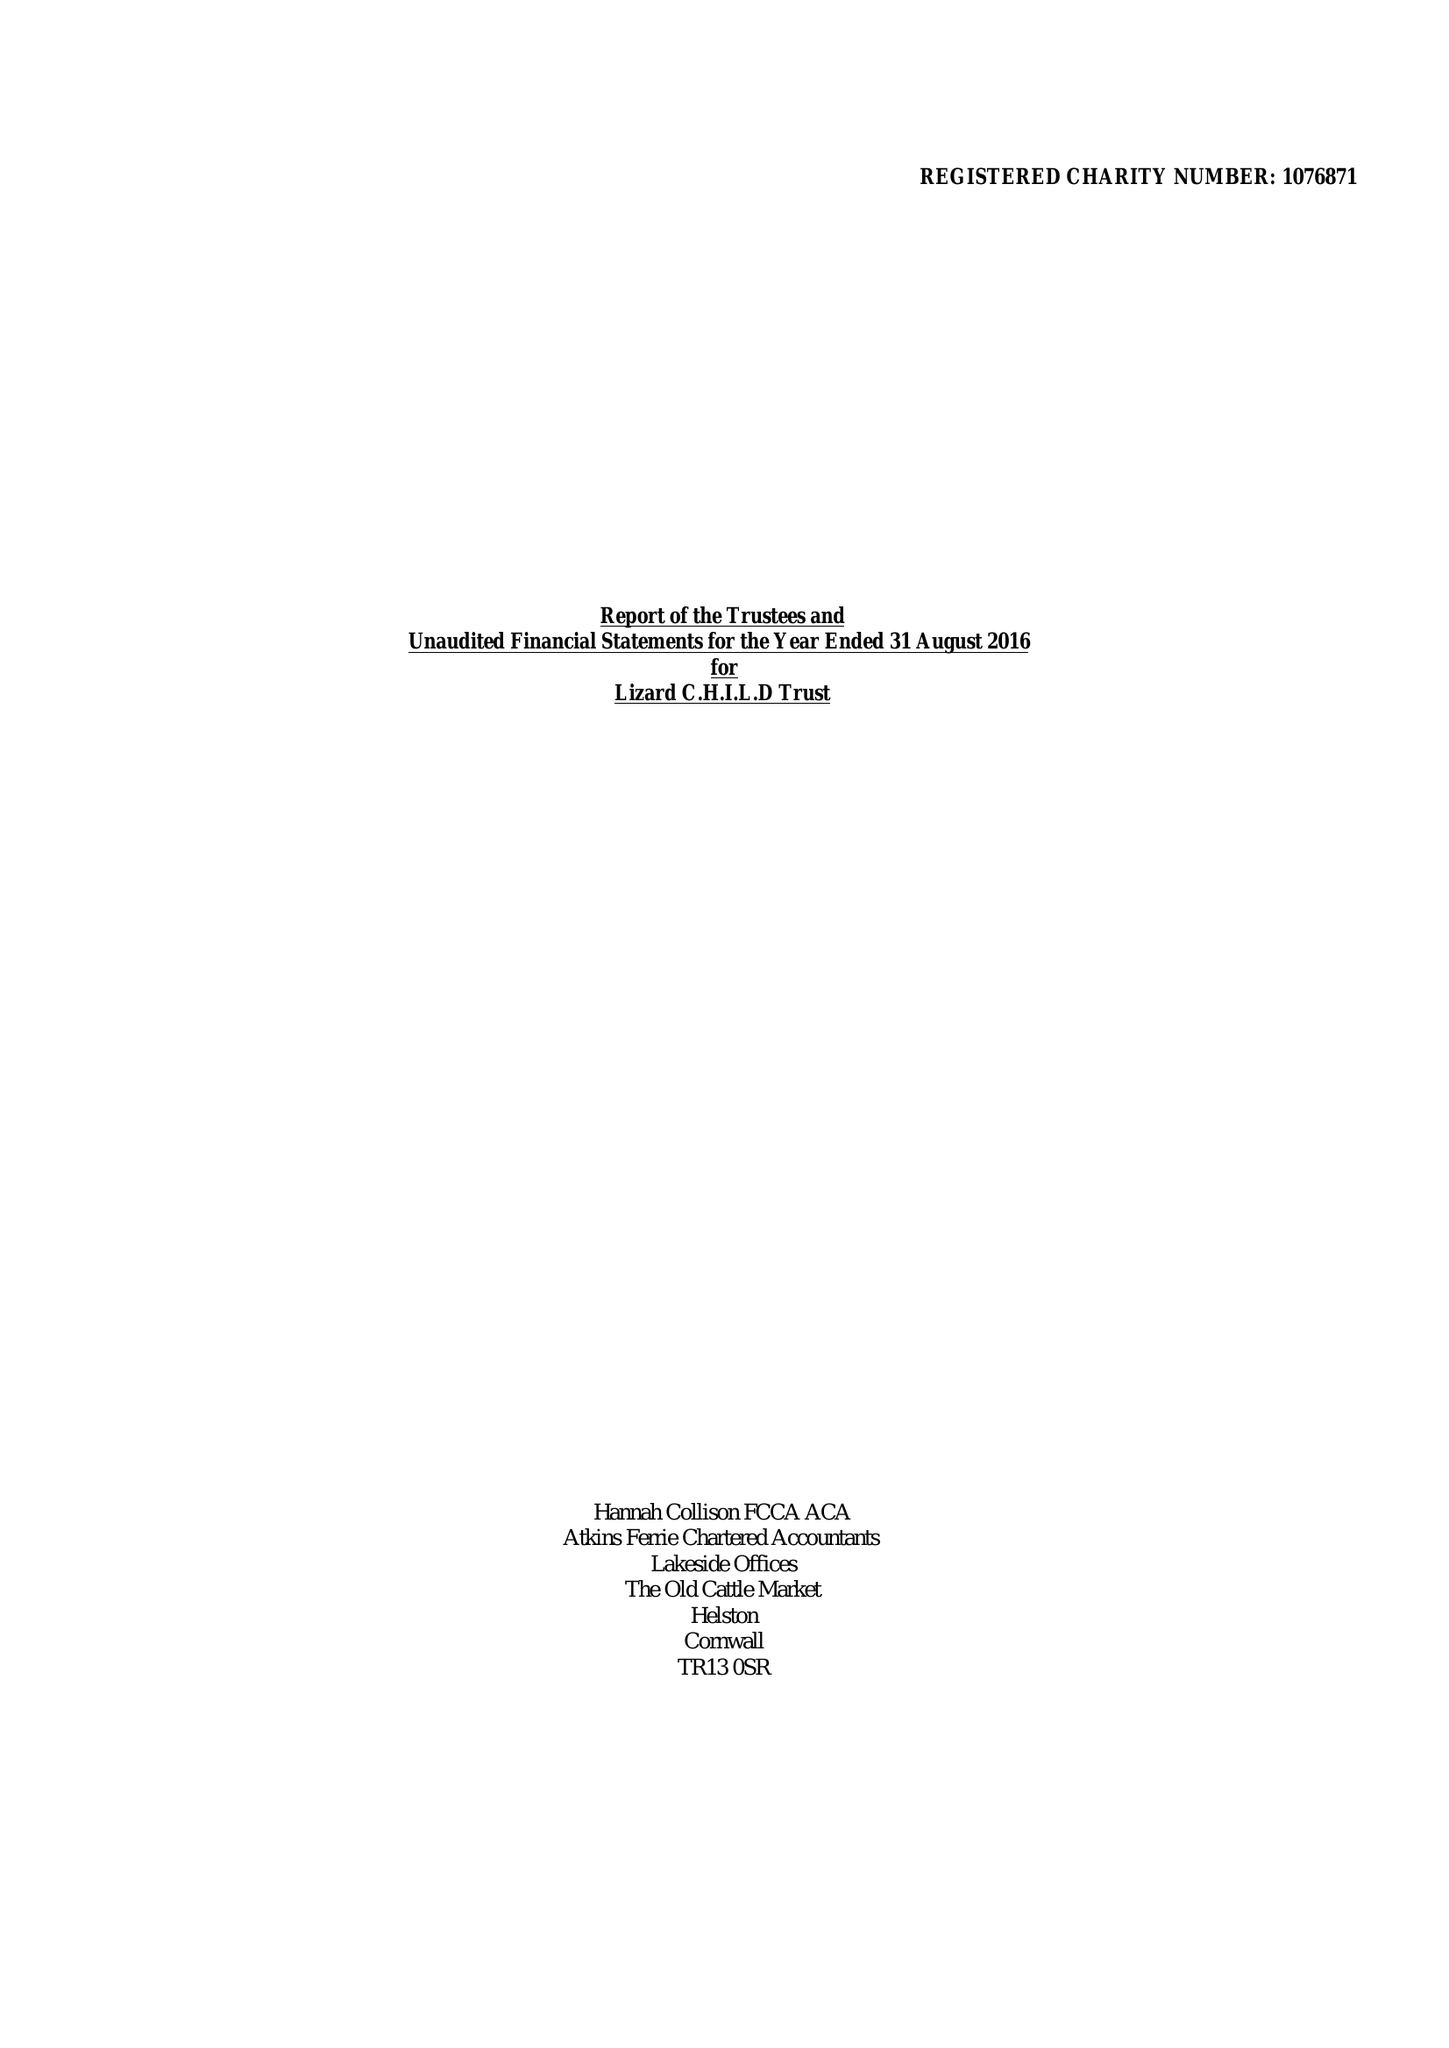What is the value for the income_annually_in_british_pounds?
Answer the question using a single word or phrase. 250702.00 